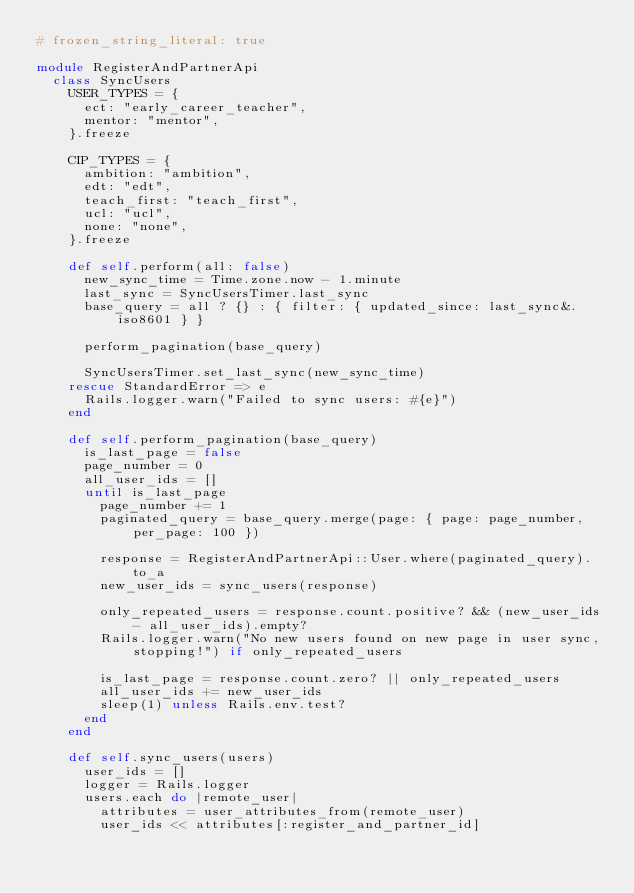<code> <loc_0><loc_0><loc_500><loc_500><_Ruby_># frozen_string_literal: true

module RegisterAndPartnerApi
  class SyncUsers
    USER_TYPES = {
      ect: "early_career_teacher",
      mentor: "mentor",
    }.freeze

    CIP_TYPES = {
      ambition: "ambition",
      edt: "edt",
      teach_first: "teach_first",
      ucl: "ucl",
      none: "none",
    }.freeze

    def self.perform(all: false)
      new_sync_time = Time.zone.now - 1.minute
      last_sync = SyncUsersTimer.last_sync
      base_query = all ? {} : { filter: { updated_since: last_sync&.iso8601 } }

      perform_pagination(base_query)

      SyncUsersTimer.set_last_sync(new_sync_time)
    rescue StandardError => e
      Rails.logger.warn("Failed to sync users: #{e}")
    end

    def self.perform_pagination(base_query)
      is_last_page = false
      page_number = 0
      all_user_ids = []
      until is_last_page
        page_number += 1
        paginated_query = base_query.merge(page: { page: page_number, per_page: 100 })

        response = RegisterAndPartnerApi::User.where(paginated_query).to_a
        new_user_ids = sync_users(response)

        only_repeated_users = response.count.positive? && (new_user_ids - all_user_ids).empty?
        Rails.logger.warn("No new users found on new page in user sync, stopping!") if only_repeated_users

        is_last_page = response.count.zero? || only_repeated_users
        all_user_ids += new_user_ids
        sleep(1) unless Rails.env.test?
      end
    end

    def self.sync_users(users)
      user_ids = []
      logger = Rails.logger
      users.each do |remote_user|
        attributes = user_attributes_from(remote_user)
        user_ids << attributes[:register_and_partner_id]
</code> 